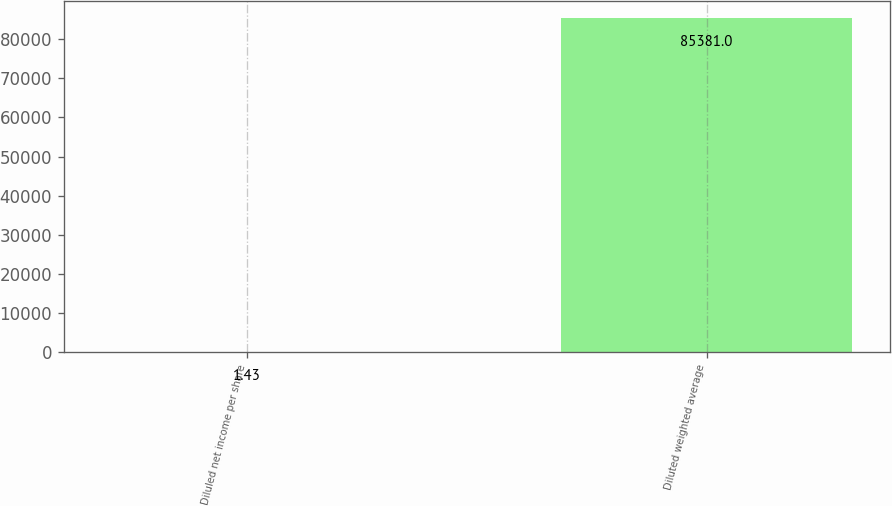<chart> <loc_0><loc_0><loc_500><loc_500><bar_chart><fcel>Diluled net income per share<fcel>Diluted weighted average<nl><fcel>1.43<fcel>85381<nl></chart> 